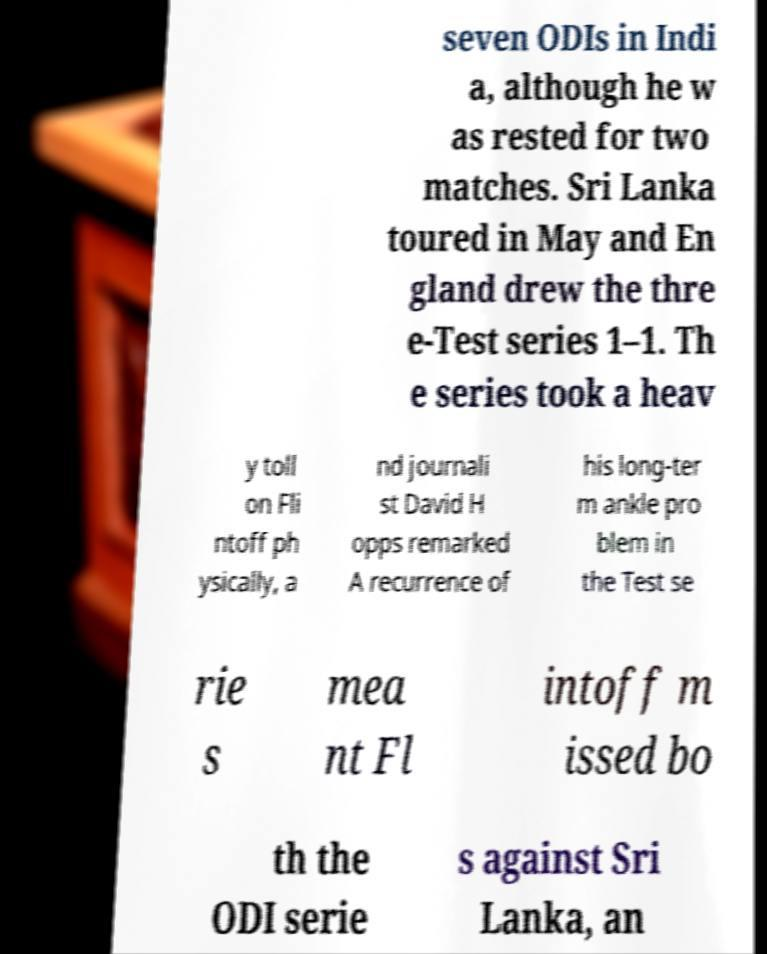Can you accurately transcribe the text from the provided image for me? seven ODIs in Indi a, although he w as rested for two matches. Sri Lanka toured in May and En gland drew the thre e-Test series 1–1. Th e series took a heav y toll on Fli ntoff ph ysically, a nd journali st David H opps remarked A recurrence of his long-ter m ankle pro blem in the Test se rie s mea nt Fl intoff m issed bo th the ODI serie s against Sri Lanka, an 